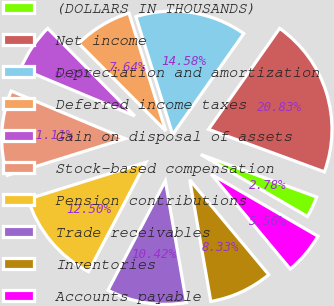Convert chart. <chart><loc_0><loc_0><loc_500><loc_500><pie_chart><fcel>(DOLLARS IN THOUSANDS)<fcel>Net income<fcel>Depreciation and amortization<fcel>Deferred income taxes<fcel>Gain on disposal of assets<fcel>Stock-based compensation<fcel>Pension contributions<fcel>Trade receivables<fcel>Inventories<fcel>Accounts payable<nl><fcel>2.78%<fcel>20.83%<fcel>14.58%<fcel>7.64%<fcel>6.25%<fcel>11.11%<fcel>12.5%<fcel>10.42%<fcel>8.33%<fcel>5.56%<nl></chart> 